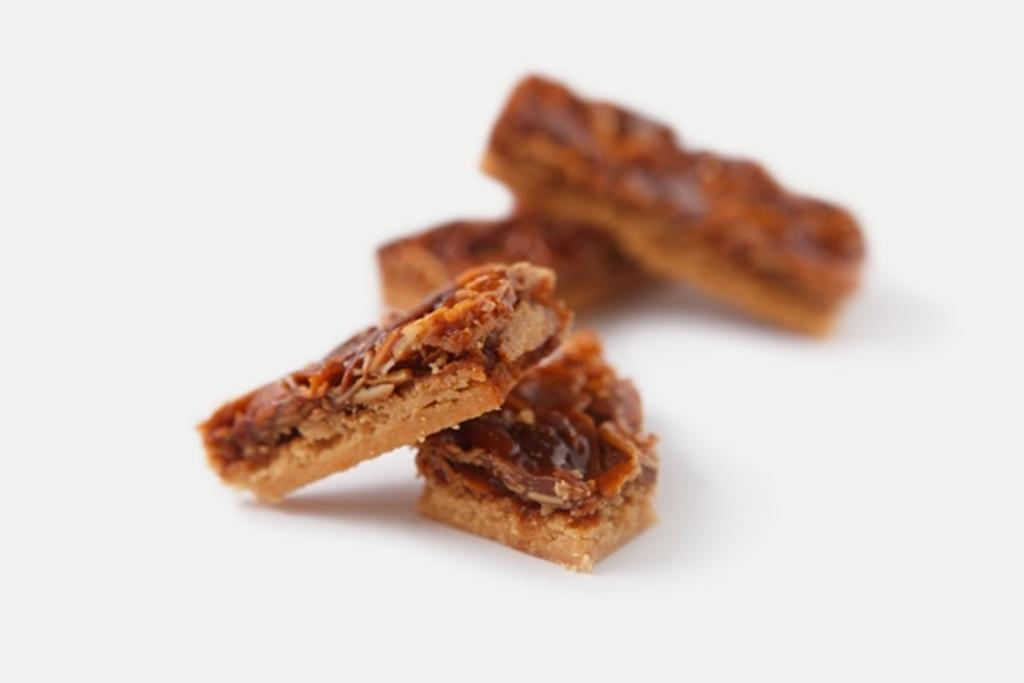What type of food can be seen in the image? There are biscuits in the image. Are the biscuits arranged in a specific pattern or design? The provided facts do not mention any specific pattern or design. Can you describe the size or shape of the biscuits? The provided facts do not mention the size or shape of the biscuits. What type of roof can be seen on the house in the image? There is no house or roof present in the image; it only features biscuits. 